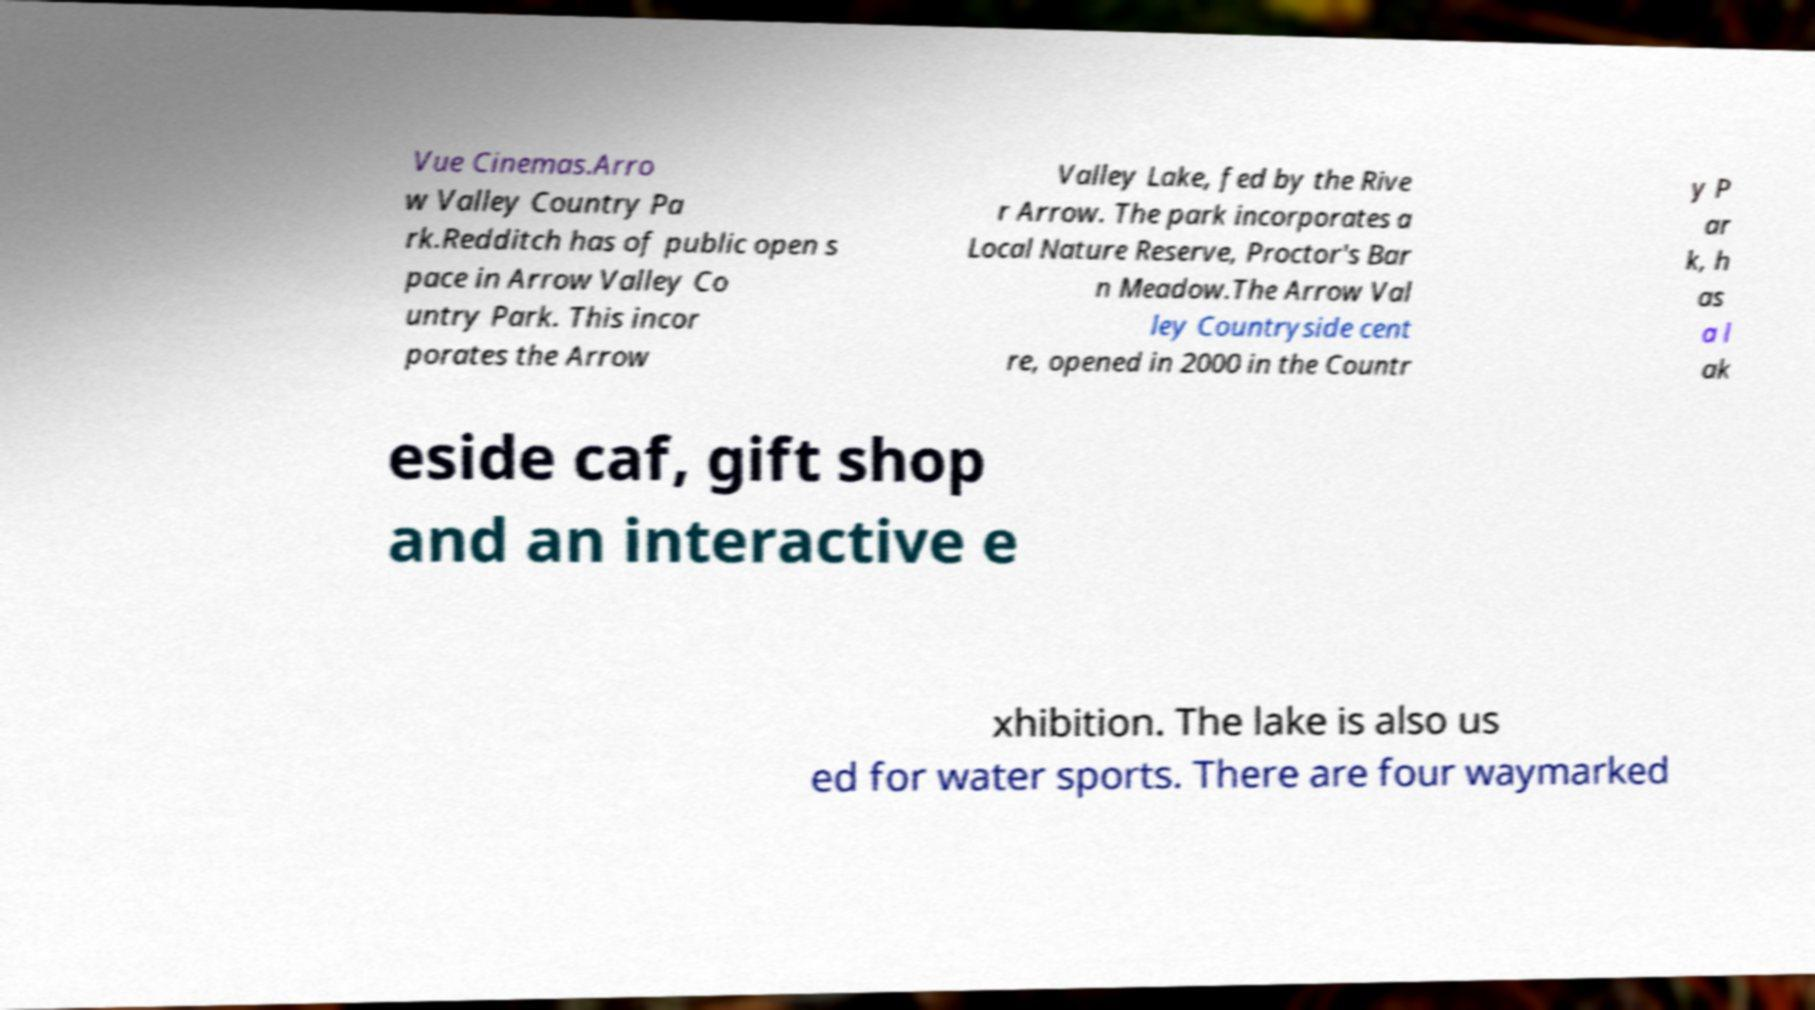Please read and relay the text visible in this image. What does it say? Vue Cinemas.Arro w Valley Country Pa rk.Redditch has of public open s pace in Arrow Valley Co untry Park. This incor porates the Arrow Valley Lake, fed by the Rive r Arrow. The park incorporates a Local Nature Reserve, Proctor's Bar n Meadow.The Arrow Val ley Countryside cent re, opened in 2000 in the Countr y P ar k, h as a l ak eside caf, gift shop and an interactive e xhibition. The lake is also us ed for water sports. There are four waymarked 